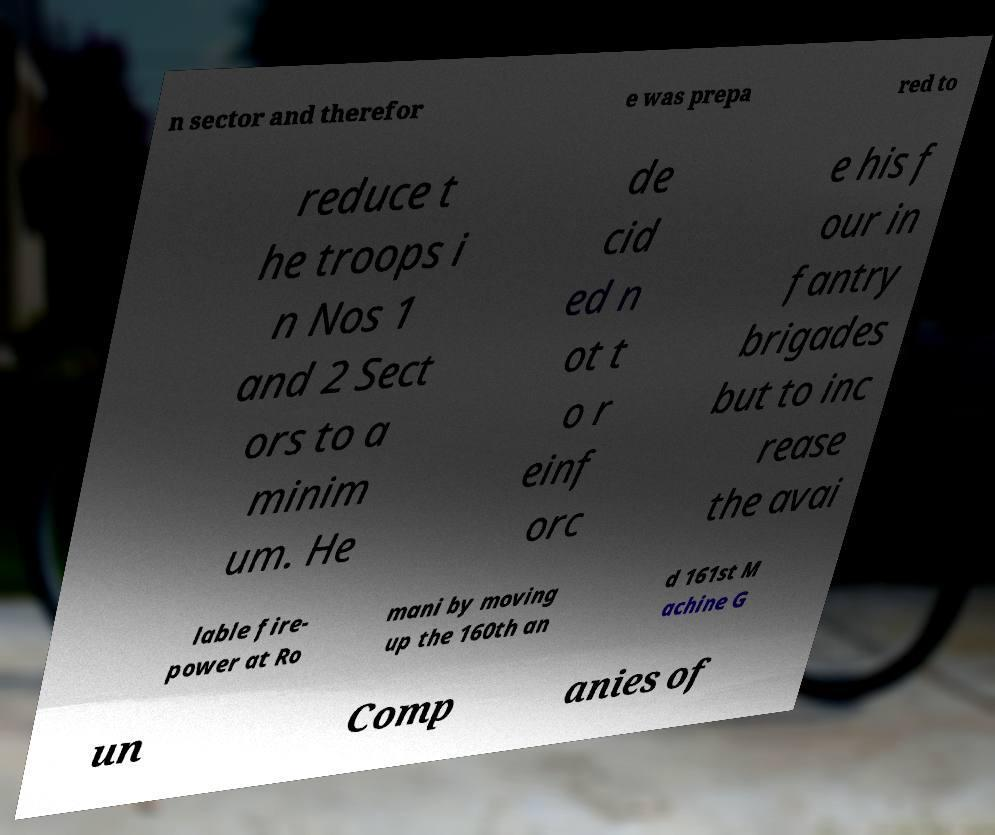Can you accurately transcribe the text from the provided image for me? n sector and therefor e was prepa red to reduce t he troops i n Nos 1 and 2 Sect ors to a minim um. He de cid ed n ot t o r einf orc e his f our in fantry brigades but to inc rease the avai lable fire- power at Ro mani by moving up the 160th an d 161st M achine G un Comp anies of 